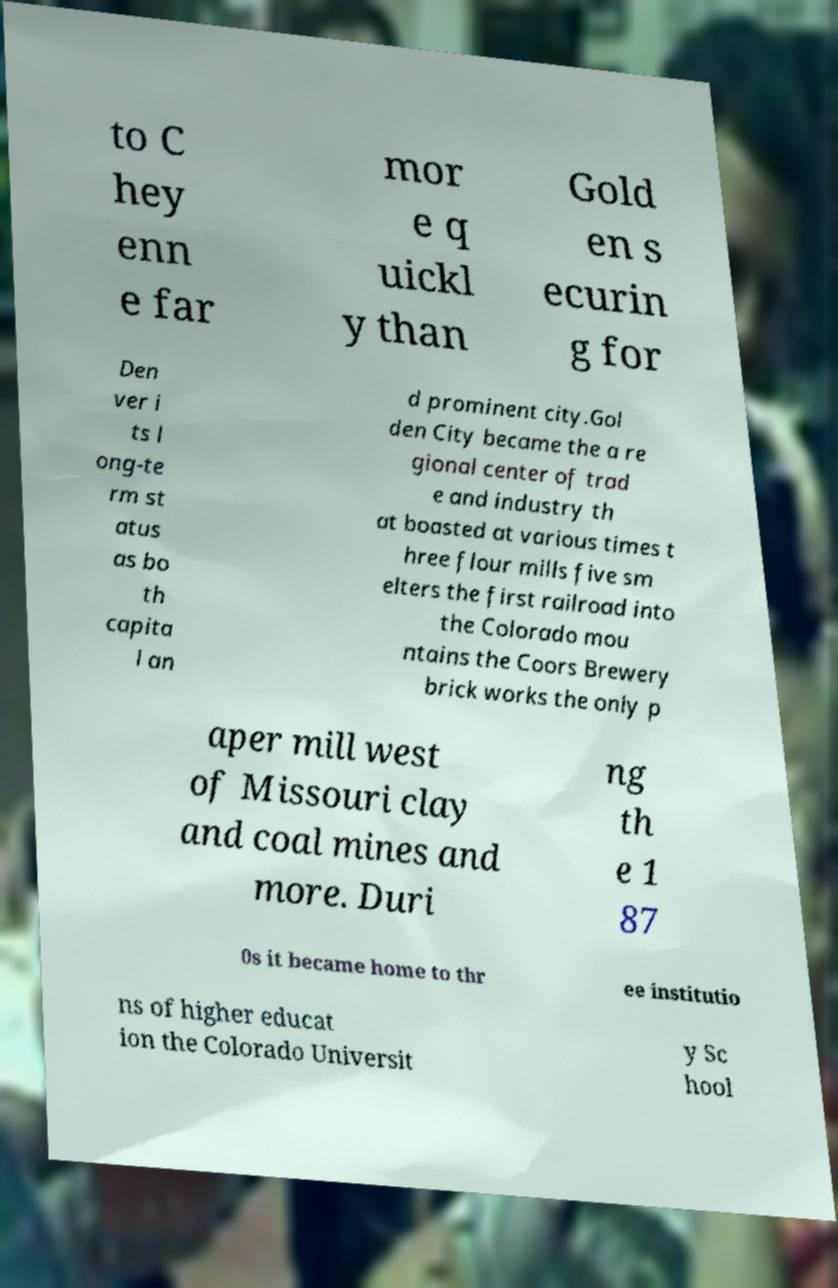Could you assist in decoding the text presented in this image and type it out clearly? to C hey enn e far mor e q uickl y than Gold en s ecurin g for Den ver i ts l ong-te rm st atus as bo th capita l an d prominent city.Gol den City became the a re gional center of trad e and industry th at boasted at various times t hree flour mills five sm elters the first railroad into the Colorado mou ntains the Coors Brewery brick works the only p aper mill west of Missouri clay and coal mines and more. Duri ng th e 1 87 0s it became home to thr ee institutio ns of higher educat ion the Colorado Universit y Sc hool 